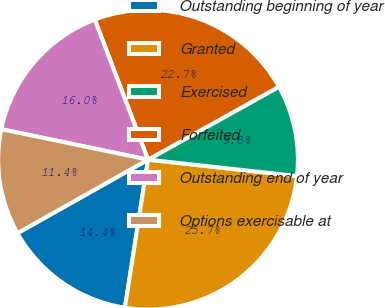<chart> <loc_0><loc_0><loc_500><loc_500><pie_chart><fcel>Outstanding beginning of year<fcel>Granted<fcel>Exercised<fcel>Forfeited<fcel>Outstanding end of year<fcel>Options exercisable at<nl><fcel>14.37%<fcel>25.72%<fcel>9.83%<fcel>22.69%<fcel>15.96%<fcel>11.42%<nl></chart> 